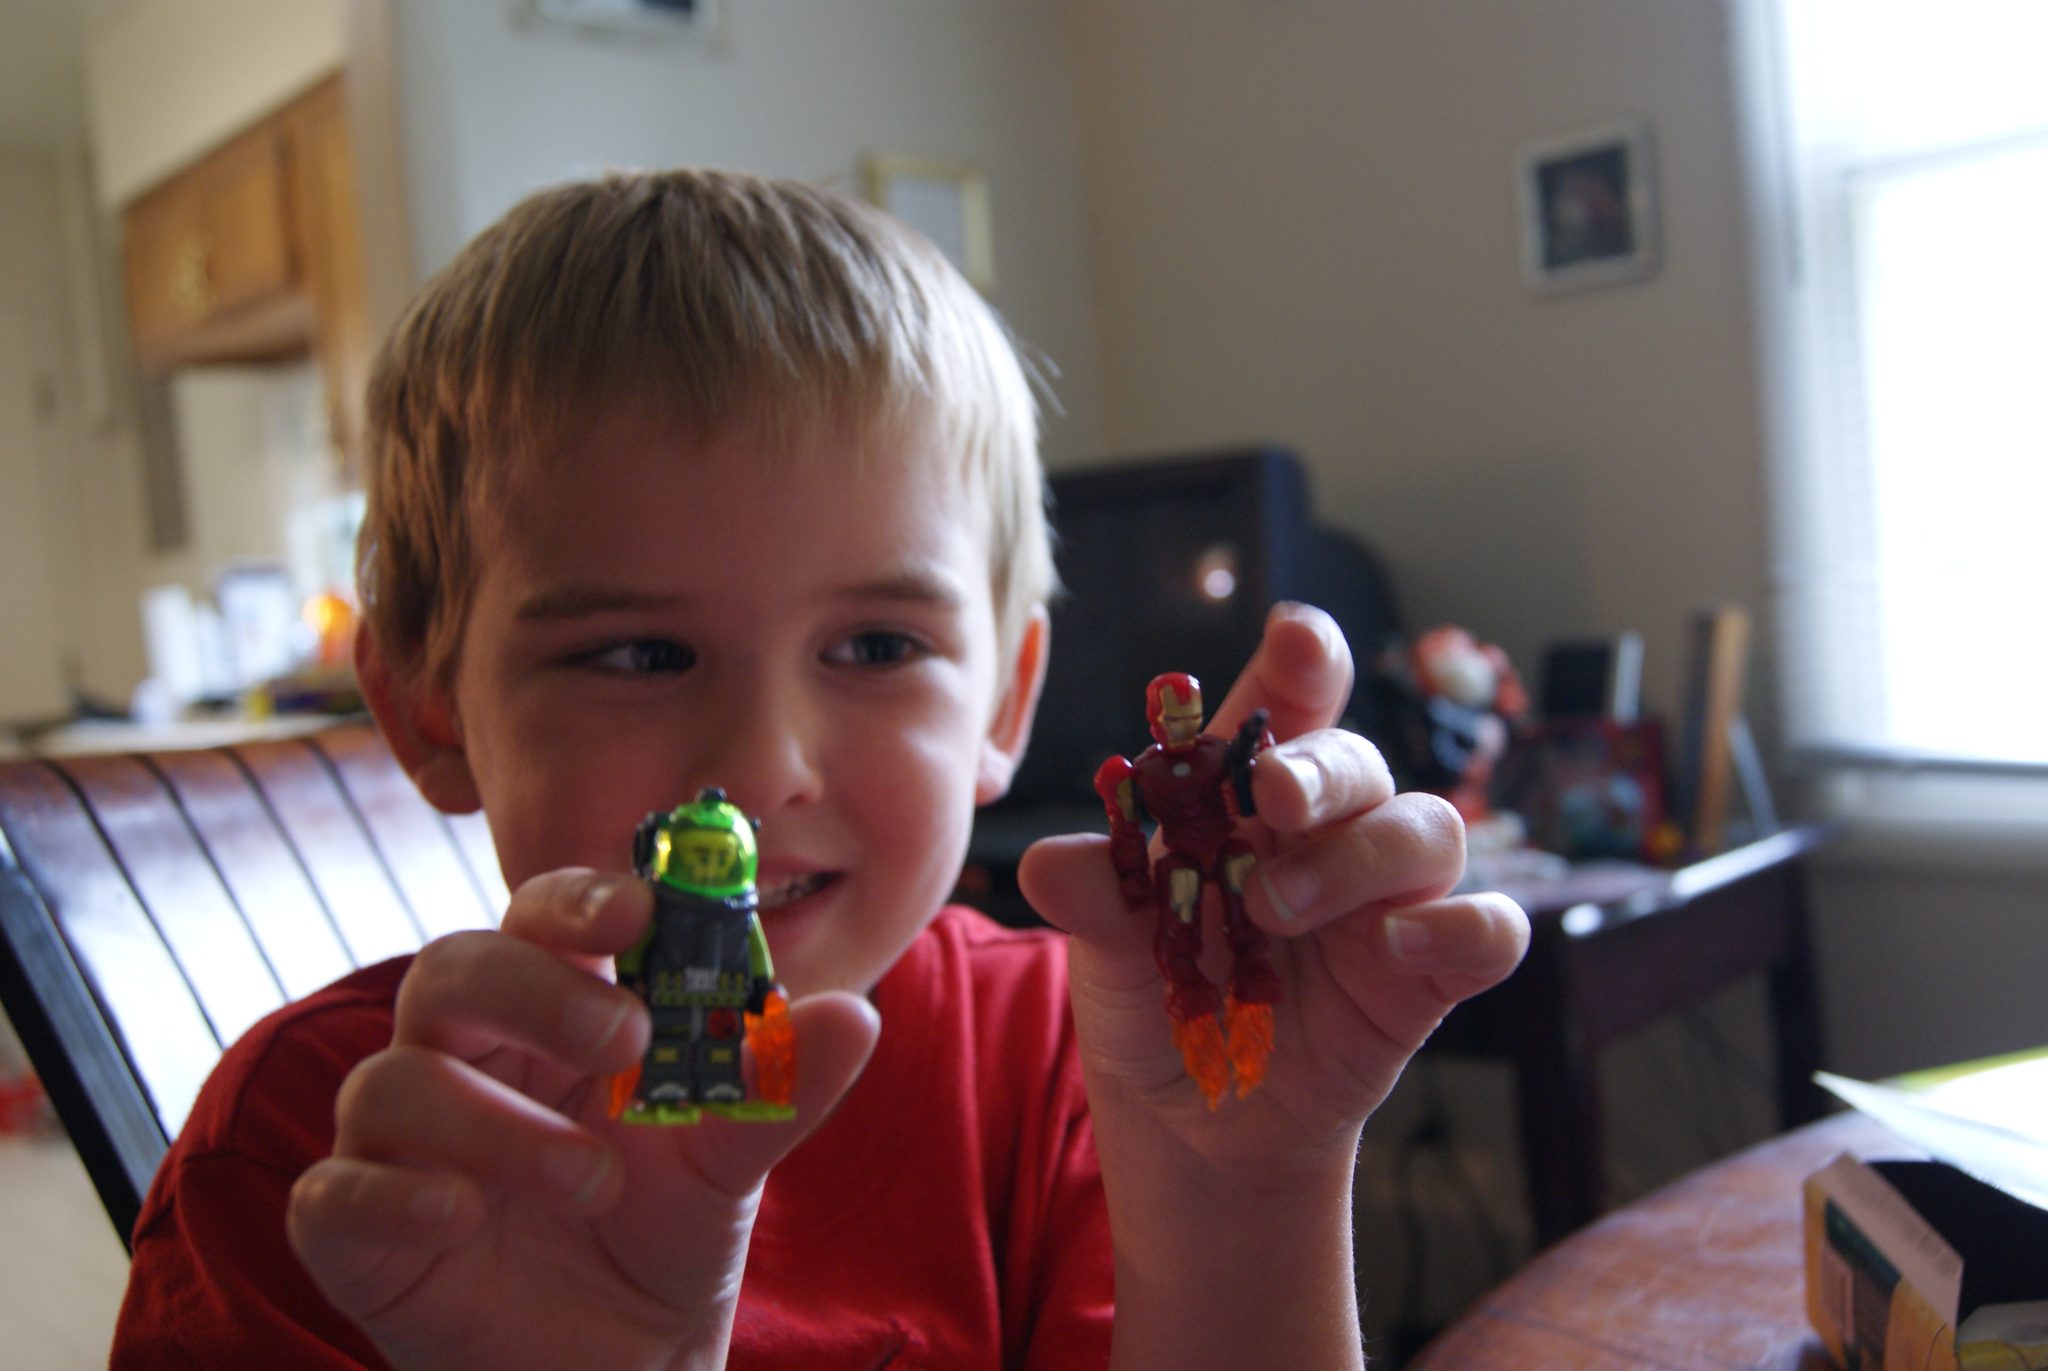In one or two sentences, can you explain what this image depicts? This image is clicked the inside a room. There is chair, table, a kid who is holding 2 cartoon toys. There is a photo frame on the top. There are Windows on the right side. On the table there is a box. Behind the boy there is television. 